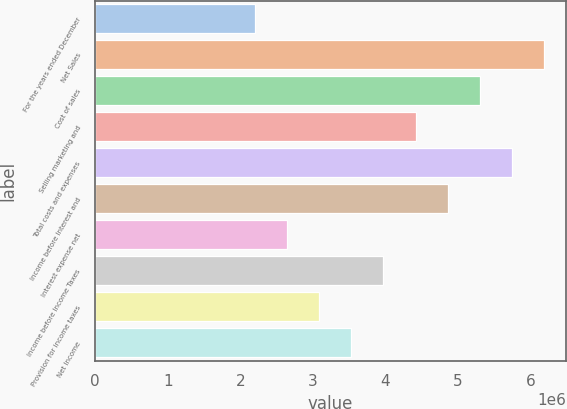<chart> <loc_0><loc_0><loc_500><loc_500><bar_chart><fcel>For the years ended December<fcel>Net Sales<fcel>Cost of sales<fcel>Selling marketing and<fcel>Total costs and expenses<fcel>Income before Interest and<fcel>Interest expense net<fcel>Income before Income Taxes<fcel>Provision for income taxes<fcel>Net Income<nl><fcel>2.20819e+06<fcel>6.18294e+06<fcel>5.29967e+06<fcel>4.41639e+06<fcel>5.74131e+06<fcel>4.85803e+06<fcel>2.64983e+06<fcel>3.97475e+06<fcel>3.09147e+06<fcel>3.53311e+06<nl></chart> 